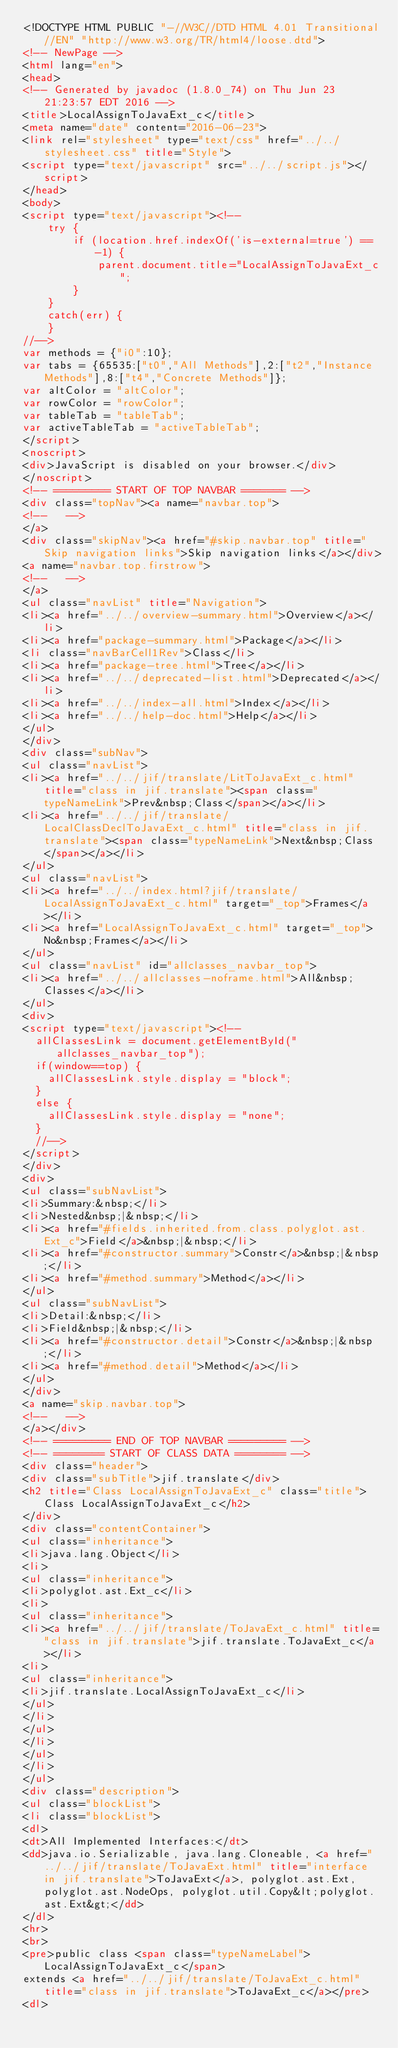Convert code to text. <code><loc_0><loc_0><loc_500><loc_500><_HTML_><!DOCTYPE HTML PUBLIC "-//W3C//DTD HTML 4.01 Transitional//EN" "http://www.w3.org/TR/html4/loose.dtd">
<!-- NewPage -->
<html lang="en">
<head>
<!-- Generated by javadoc (1.8.0_74) on Thu Jun 23 21:23:57 EDT 2016 -->
<title>LocalAssignToJavaExt_c</title>
<meta name="date" content="2016-06-23">
<link rel="stylesheet" type="text/css" href="../../stylesheet.css" title="Style">
<script type="text/javascript" src="../../script.js"></script>
</head>
<body>
<script type="text/javascript"><!--
    try {
        if (location.href.indexOf('is-external=true') == -1) {
            parent.document.title="LocalAssignToJavaExt_c";
        }
    }
    catch(err) {
    }
//-->
var methods = {"i0":10};
var tabs = {65535:["t0","All Methods"],2:["t2","Instance Methods"],8:["t4","Concrete Methods"]};
var altColor = "altColor";
var rowColor = "rowColor";
var tableTab = "tableTab";
var activeTableTab = "activeTableTab";
</script>
<noscript>
<div>JavaScript is disabled on your browser.</div>
</noscript>
<!-- ========= START OF TOP NAVBAR ======= -->
<div class="topNav"><a name="navbar.top">
<!--   -->
</a>
<div class="skipNav"><a href="#skip.navbar.top" title="Skip navigation links">Skip navigation links</a></div>
<a name="navbar.top.firstrow">
<!--   -->
</a>
<ul class="navList" title="Navigation">
<li><a href="../../overview-summary.html">Overview</a></li>
<li><a href="package-summary.html">Package</a></li>
<li class="navBarCell1Rev">Class</li>
<li><a href="package-tree.html">Tree</a></li>
<li><a href="../../deprecated-list.html">Deprecated</a></li>
<li><a href="../../index-all.html">Index</a></li>
<li><a href="../../help-doc.html">Help</a></li>
</ul>
</div>
<div class="subNav">
<ul class="navList">
<li><a href="../../jif/translate/LitToJavaExt_c.html" title="class in jif.translate"><span class="typeNameLink">Prev&nbsp;Class</span></a></li>
<li><a href="../../jif/translate/LocalClassDeclToJavaExt_c.html" title="class in jif.translate"><span class="typeNameLink">Next&nbsp;Class</span></a></li>
</ul>
<ul class="navList">
<li><a href="../../index.html?jif/translate/LocalAssignToJavaExt_c.html" target="_top">Frames</a></li>
<li><a href="LocalAssignToJavaExt_c.html" target="_top">No&nbsp;Frames</a></li>
</ul>
<ul class="navList" id="allclasses_navbar_top">
<li><a href="../../allclasses-noframe.html">All&nbsp;Classes</a></li>
</ul>
<div>
<script type="text/javascript"><!--
  allClassesLink = document.getElementById("allclasses_navbar_top");
  if(window==top) {
    allClassesLink.style.display = "block";
  }
  else {
    allClassesLink.style.display = "none";
  }
  //-->
</script>
</div>
<div>
<ul class="subNavList">
<li>Summary:&nbsp;</li>
<li>Nested&nbsp;|&nbsp;</li>
<li><a href="#fields.inherited.from.class.polyglot.ast.Ext_c">Field</a>&nbsp;|&nbsp;</li>
<li><a href="#constructor.summary">Constr</a>&nbsp;|&nbsp;</li>
<li><a href="#method.summary">Method</a></li>
</ul>
<ul class="subNavList">
<li>Detail:&nbsp;</li>
<li>Field&nbsp;|&nbsp;</li>
<li><a href="#constructor.detail">Constr</a>&nbsp;|&nbsp;</li>
<li><a href="#method.detail">Method</a></li>
</ul>
</div>
<a name="skip.navbar.top">
<!--   -->
</a></div>
<!-- ========= END OF TOP NAVBAR ========= -->
<!-- ======== START OF CLASS DATA ======== -->
<div class="header">
<div class="subTitle">jif.translate</div>
<h2 title="Class LocalAssignToJavaExt_c" class="title">Class LocalAssignToJavaExt_c</h2>
</div>
<div class="contentContainer">
<ul class="inheritance">
<li>java.lang.Object</li>
<li>
<ul class="inheritance">
<li>polyglot.ast.Ext_c</li>
<li>
<ul class="inheritance">
<li><a href="../../jif/translate/ToJavaExt_c.html" title="class in jif.translate">jif.translate.ToJavaExt_c</a></li>
<li>
<ul class="inheritance">
<li>jif.translate.LocalAssignToJavaExt_c</li>
</ul>
</li>
</ul>
</li>
</ul>
</li>
</ul>
<div class="description">
<ul class="blockList">
<li class="blockList">
<dl>
<dt>All Implemented Interfaces:</dt>
<dd>java.io.Serializable, java.lang.Cloneable, <a href="../../jif/translate/ToJavaExt.html" title="interface in jif.translate">ToJavaExt</a>, polyglot.ast.Ext, polyglot.ast.NodeOps, polyglot.util.Copy&lt;polyglot.ast.Ext&gt;</dd>
</dl>
<hr>
<br>
<pre>public class <span class="typeNameLabel">LocalAssignToJavaExt_c</span>
extends <a href="../../jif/translate/ToJavaExt_c.html" title="class in jif.translate">ToJavaExt_c</a></pre>
<dl></code> 